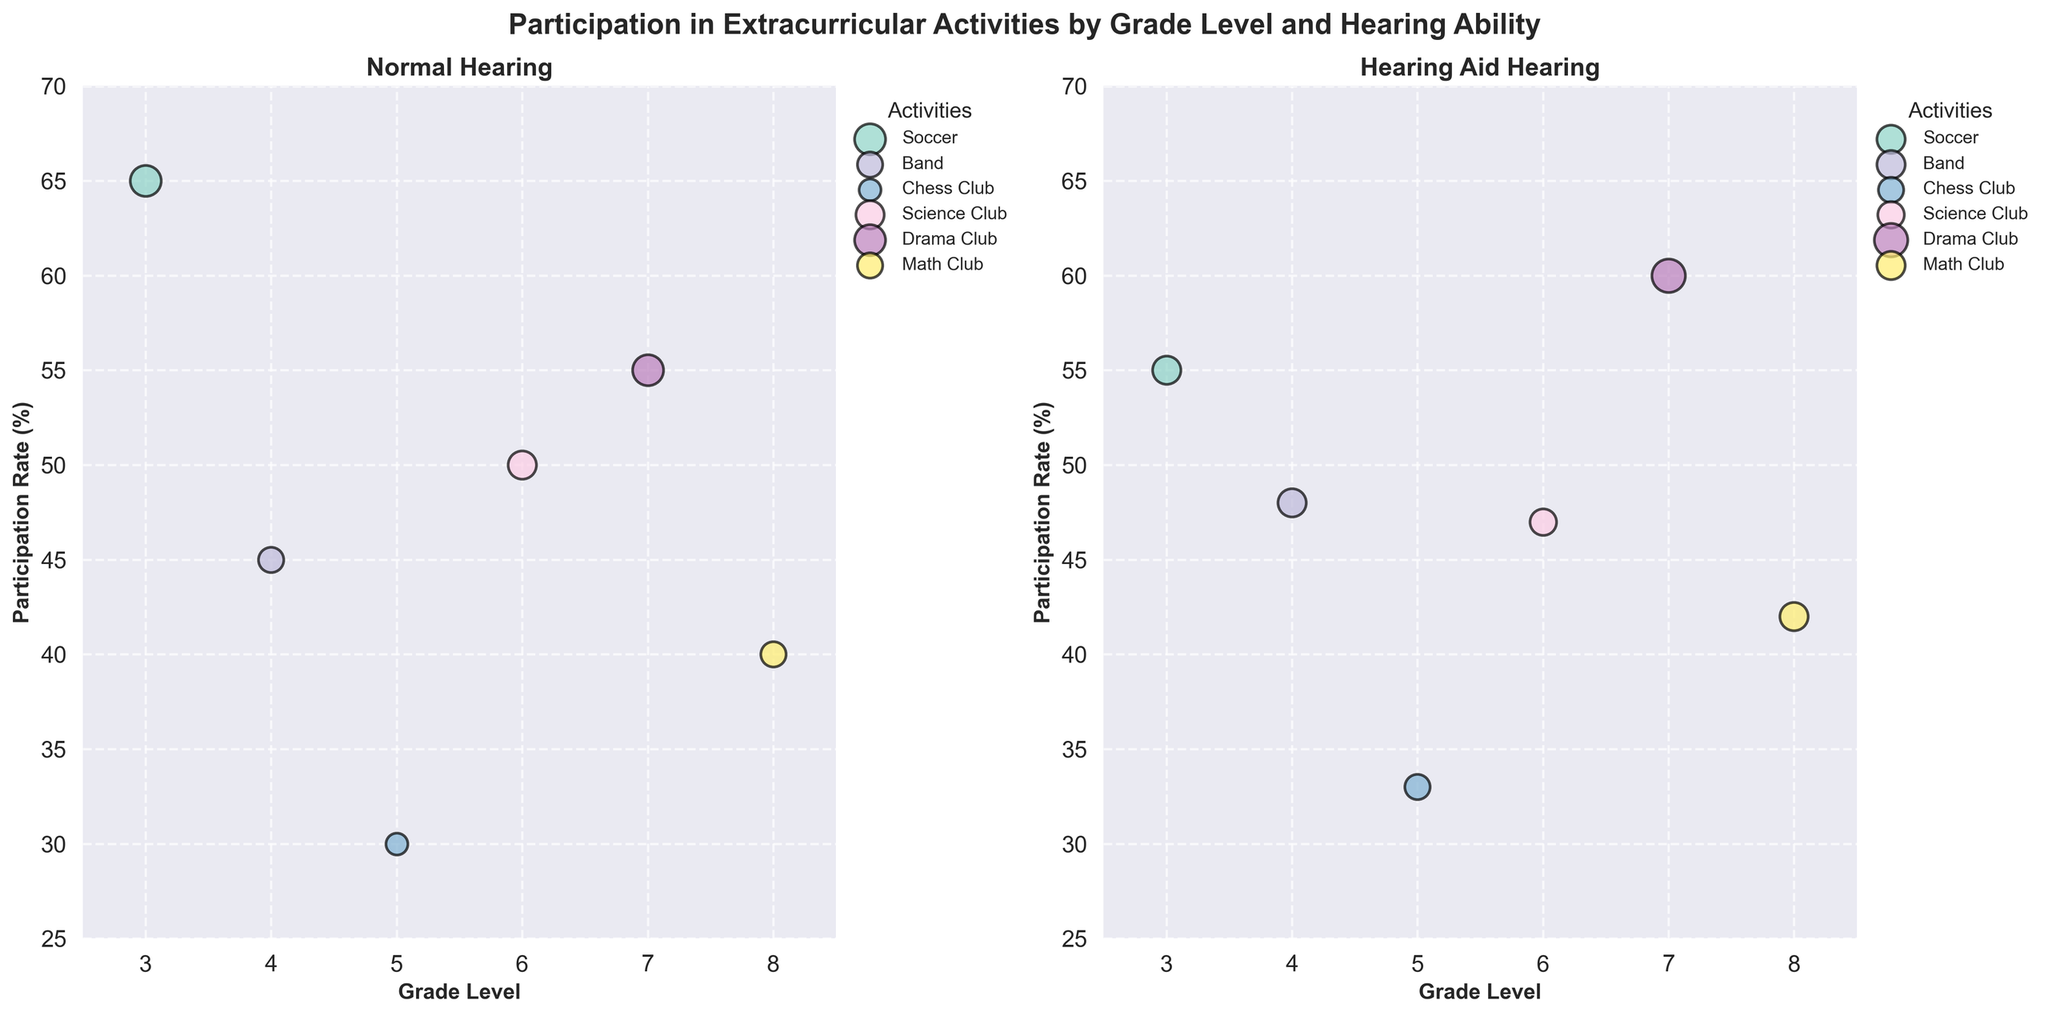what are the titles of the subplots? The titles of the subplots are displayed above each subplot. The left subplot is titled "Normal Hearing" and the right subplot is titled "Hearing Aid."
Answer: "Normal Hearing" and "Hearing Aid" What is the participation rate for Drama Club for students with hearing aids? The participation rate for Drama Club students with hearing aids is indicated by the y-axis position of the bubble in the "Hearing Aid" subplot for grade 7. It aligns with a value of 60%.
Answer: 60% How do the participation rates for Band in grade 4 compare between students with normal hearing and students with hearing aids? In the "Normal Hearing" subplot for grade 4 (x-axis), the Band activity (one of the bubbles) is at a participation rate (y-axis) of 45%. In the "Hearing Aid" subplot, the Band activity for grade 4 is at a participation rate of 48%.
Answer: Band participation is 45% for normal hearing and 48% for hearing aids Which extracurricular activity has the largest average hours per week for students with hearing aids and how can you tell? The size of the bubble indicates the average hours per week. In the "Hearing Aid" subplot, Drama Club in grade 7 has the largest size bubble compared to the other activities.
Answer: Drama Club Which extracurricular activity has the lowest participation rate for students with normal hearing? In the "Normal Hearing" subplot, the bubble with the lowest position on the y-axis represents the lowest participation rate. The bubble in grade 5 for Chess Club is at 30%.
Answer: Chess Club What is the difference in participation rate between Science Club and Math Club for students with hearing aids? In the "Hearing Aid" subplot for grades 6 and 8, Science Club is at a 47% participation rate and Math Club is at 42%. The difference is 47% - 42%.
Answer: 5% Add up the number of participants in extracurricular activities for grade 3 and 4 for normal hearing students. For normal hearing students in grade 3, Soccer has 520 participants. In grade 4, Band has 360 participants. Adding them up gives 520 + 360.
Answer: 880 How many activities have a higher participation rate for students with hearing aids than for students with normal hearing within the same grade? By comparing pairs of bubbles in each subplot for the same grade levels: Band in grade 4, Chess Club in grade 5, and Drama Club in grade 7 have higher participation rates for students with hearing aids than for students with normal hearing.
Answer: 3 